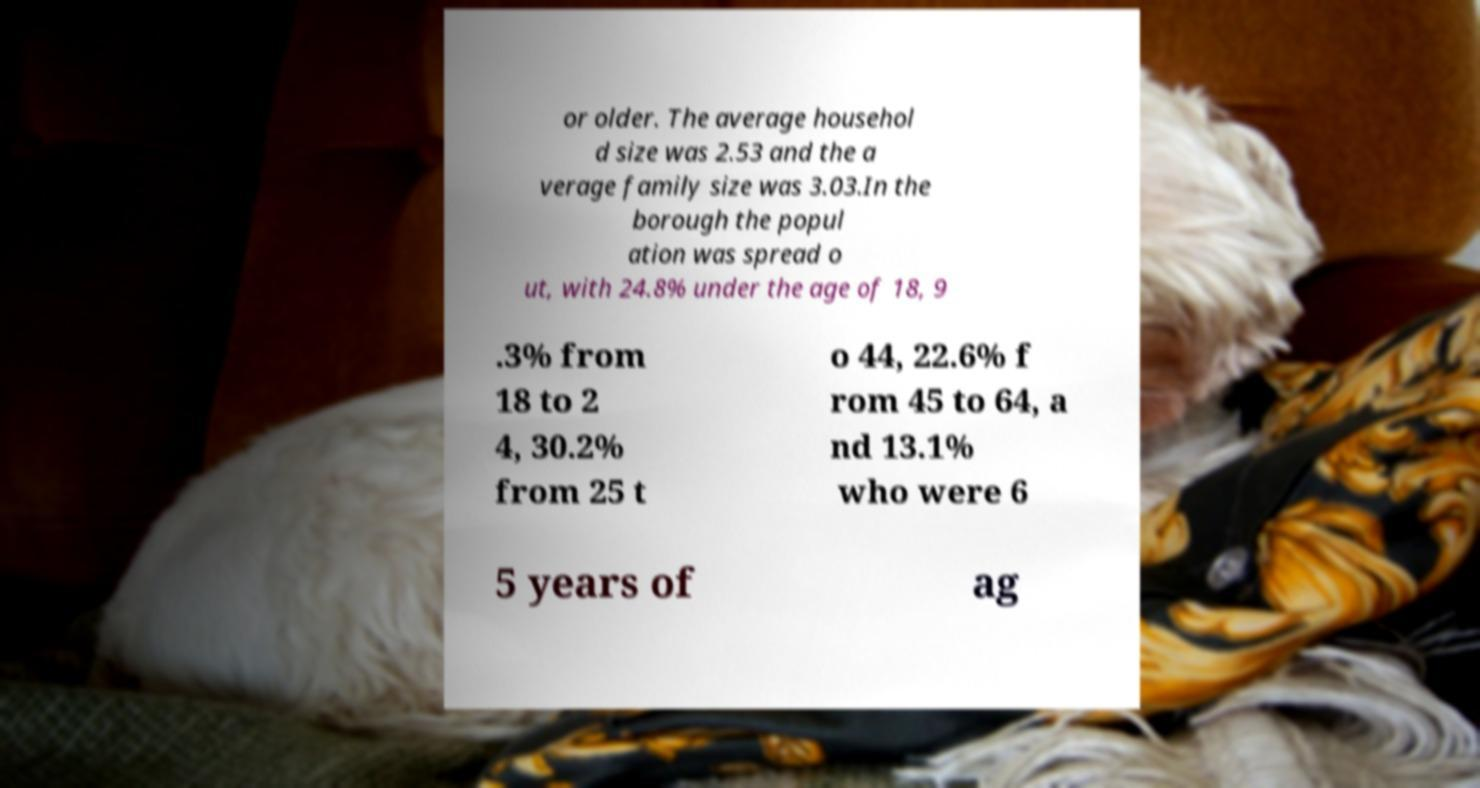For documentation purposes, I need the text within this image transcribed. Could you provide that? or older. The average househol d size was 2.53 and the a verage family size was 3.03.In the borough the popul ation was spread o ut, with 24.8% under the age of 18, 9 .3% from 18 to 2 4, 30.2% from 25 t o 44, 22.6% f rom 45 to 64, a nd 13.1% who were 6 5 years of ag 